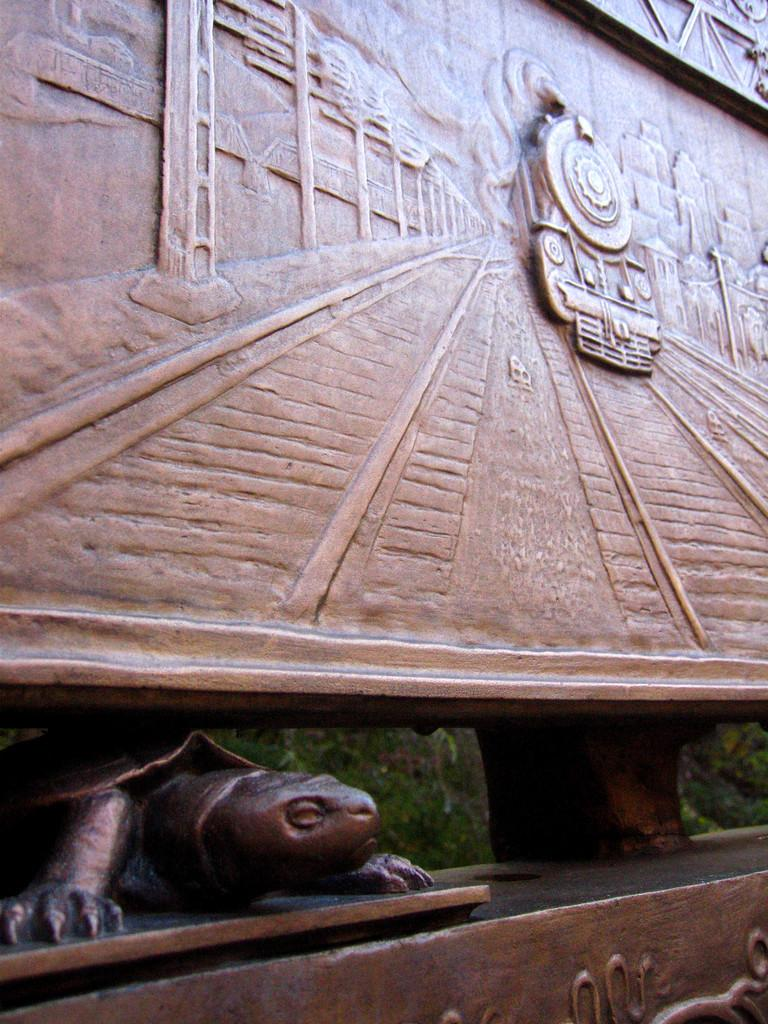What is the main subject of the picture? The main subject of the picture is a sculpture. What other objects or images can be seen in the picture? There is an image of a train and images of buildings in the picture. Are there any animals present in the picture? Yes, there is a tortoise in the picture. What type of jam is being spread on the tortoise in the image? There is no jam present in the image, nor is there any indication that the tortoise is being used in a jam-related context. 